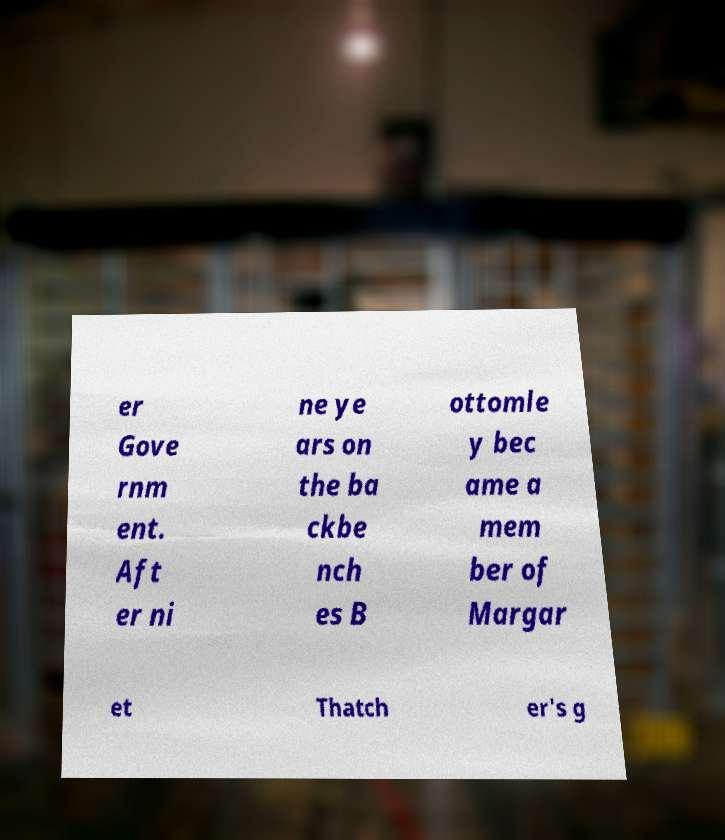Can you accurately transcribe the text from the provided image for me? er Gove rnm ent. Aft er ni ne ye ars on the ba ckbe nch es B ottomle y bec ame a mem ber of Margar et Thatch er's g 